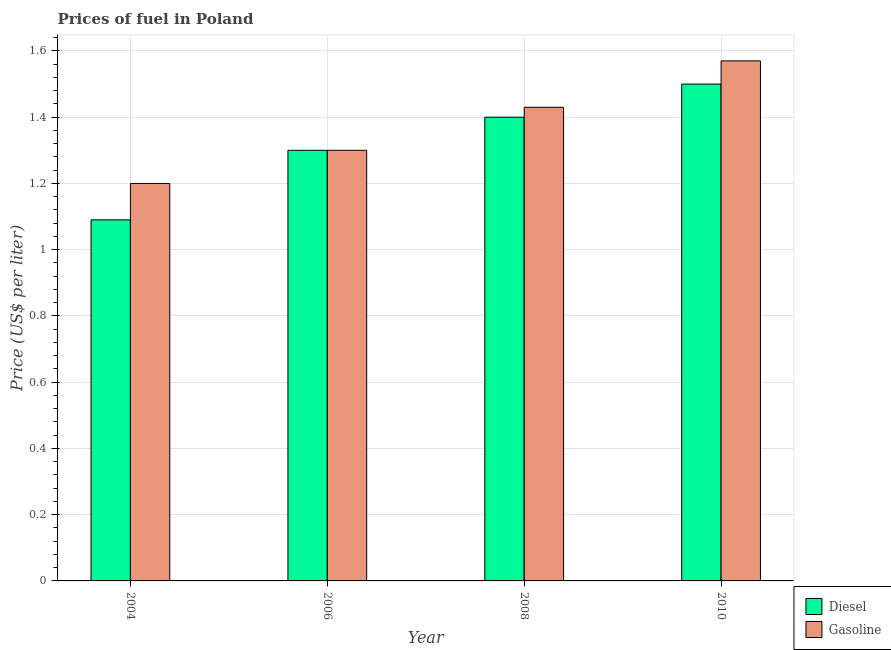How many groups of bars are there?
Offer a very short reply. 4. Are the number of bars on each tick of the X-axis equal?
Give a very brief answer. Yes. How many bars are there on the 1st tick from the right?
Offer a terse response. 2. What is the label of the 4th group of bars from the left?
Your answer should be very brief. 2010. What is the gasoline price in 2010?
Keep it short and to the point. 1.57. Across all years, what is the maximum gasoline price?
Ensure brevity in your answer.  1.57. Across all years, what is the minimum diesel price?
Offer a terse response. 1.09. In which year was the gasoline price maximum?
Your answer should be very brief. 2010. In which year was the diesel price minimum?
Your response must be concise. 2004. What is the total diesel price in the graph?
Offer a very short reply. 5.29. What is the difference between the diesel price in 2008 and that in 2010?
Make the answer very short. -0.1. What is the difference between the diesel price in 2008 and the gasoline price in 2004?
Ensure brevity in your answer.  0.31. What is the average gasoline price per year?
Ensure brevity in your answer.  1.38. In the year 2006, what is the difference between the gasoline price and diesel price?
Give a very brief answer. 0. In how many years, is the diesel price greater than 1.08 US$ per litre?
Your answer should be compact. 4. What is the ratio of the diesel price in 2004 to that in 2006?
Offer a terse response. 0.84. Is the diesel price in 2004 less than that in 2008?
Make the answer very short. Yes. Is the difference between the gasoline price in 2004 and 2008 greater than the difference between the diesel price in 2004 and 2008?
Give a very brief answer. No. What is the difference between the highest and the second highest gasoline price?
Keep it short and to the point. 0.14. What is the difference between the highest and the lowest diesel price?
Your answer should be very brief. 0.41. In how many years, is the diesel price greater than the average diesel price taken over all years?
Provide a short and direct response. 2. Is the sum of the diesel price in 2004 and 2008 greater than the maximum gasoline price across all years?
Offer a very short reply. Yes. What does the 1st bar from the left in 2006 represents?
Give a very brief answer. Diesel. What does the 1st bar from the right in 2010 represents?
Offer a very short reply. Gasoline. How many bars are there?
Your response must be concise. 8. Are all the bars in the graph horizontal?
Ensure brevity in your answer.  No. What is the title of the graph?
Provide a short and direct response. Prices of fuel in Poland. What is the label or title of the X-axis?
Your response must be concise. Year. What is the label or title of the Y-axis?
Your response must be concise. Price (US$ per liter). What is the Price (US$ per liter) in Diesel in 2004?
Your answer should be very brief. 1.09. What is the Price (US$ per liter) of Diesel in 2006?
Ensure brevity in your answer.  1.3. What is the Price (US$ per liter) of Gasoline in 2006?
Offer a very short reply. 1.3. What is the Price (US$ per liter) of Gasoline in 2008?
Your response must be concise. 1.43. What is the Price (US$ per liter) of Diesel in 2010?
Make the answer very short. 1.5. What is the Price (US$ per liter) in Gasoline in 2010?
Offer a terse response. 1.57. Across all years, what is the maximum Price (US$ per liter) in Gasoline?
Your answer should be very brief. 1.57. Across all years, what is the minimum Price (US$ per liter) of Diesel?
Offer a terse response. 1.09. Across all years, what is the minimum Price (US$ per liter) of Gasoline?
Offer a terse response. 1.2. What is the total Price (US$ per liter) of Diesel in the graph?
Offer a very short reply. 5.29. What is the difference between the Price (US$ per liter) in Diesel in 2004 and that in 2006?
Provide a succinct answer. -0.21. What is the difference between the Price (US$ per liter) in Gasoline in 2004 and that in 2006?
Make the answer very short. -0.1. What is the difference between the Price (US$ per liter) in Diesel in 2004 and that in 2008?
Offer a very short reply. -0.31. What is the difference between the Price (US$ per liter) of Gasoline in 2004 and that in 2008?
Offer a very short reply. -0.23. What is the difference between the Price (US$ per liter) of Diesel in 2004 and that in 2010?
Provide a short and direct response. -0.41. What is the difference between the Price (US$ per liter) in Gasoline in 2004 and that in 2010?
Make the answer very short. -0.37. What is the difference between the Price (US$ per liter) in Gasoline in 2006 and that in 2008?
Keep it short and to the point. -0.13. What is the difference between the Price (US$ per liter) of Diesel in 2006 and that in 2010?
Your response must be concise. -0.2. What is the difference between the Price (US$ per liter) in Gasoline in 2006 and that in 2010?
Provide a short and direct response. -0.27. What is the difference between the Price (US$ per liter) of Gasoline in 2008 and that in 2010?
Make the answer very short. -0.14. What is the difference between the Price (US$ per liter) of Diesel in 2004 and the Price (US$ per liter) of Gasoline in 2006?
Ensure brevity in your answer.  -0.21. What is the difference between the Price (US$ per liter) of Diesel in 2004 and the Price (US$ per liter) of Gasoline in 2008?
Provide a short and direct response. -0.34. What is the difference between the Price (US$ per liter) of Diesel in 2004 and the Price (US$ per liter) of Gasoline in 2010?
Provide a succinct answer. -0.48. What is the difference between the Price (US$ per liter) of Diesel in 2006 and the Price (US$ per liter) of Gasoline in 2008?
Make the answer very short. -0.13. What is the difference between the Price (US$ per liter) of Diesel in 2006 and the Price (US$ per liter) of Gasoline in 2010?
Your response must be concise. -0.27. What is the difference between the Price (US$ per liter) in Diesel in 2008 and the Price (US$ per liter) in Gasoline in 2010?
Make the answer very short. -0.17. What is the average Price (US$ per liter) of Diesel per year?
Keep it short and to the point. 1.32. What is the average Price (US$ per liter) in Gasoline per year?
Offer a very short reply. 1.38. In the year 2004, what is the difference between the Price (US$ per liter) of Diesel and Price (US$ per liter) of Gasoline?
Offer a very short reply. -0.11. In the year 2008, what is the difference between the Price (US$ per liter) in Diesel and Price (US$ per liter) in Gasoline?
Make the answer very short. -0.03. In the year 2010, what is the difference between the Price (US$ per liter) of Diesel and Price (US$ per liter) of Gasoline?
Provide a succinct answer. -0.07. What is the ratio of the Price (US$ per liter) in Diesel in 2004 to that in 2006?
Your answer should be compact. 0.84. What is the ratio of the Price (US$ per liter) in Diesel in 2004 to that in 2008?
Your response must be concise. 0.78. What is the ratio of the Price (US$ per liter) in Gasoline in 2004 to that in 2008?
Offer a terse response. 0.84. What is the ratio of the Price (US$ per liter) in Diesel in 2004 to that in 2010?
Keep it short and to the point. 0.73. What is the ratio of the Price (US$ per liter) in Gasoline in 2004 to that in 2010?
Your answer should be compact. 0.76. What is the ratio of the Price (US$ per liter) of Gasoline in 2006 to that in 2008?
Give a very brief answer. 0.91. What is the ratio of the Price (US$ per liter) of Diesel in 2006 to that in 2010?
Ensure brevity in your answer.  0.87. What is the ratio of the Price (US$ per liter) in Gasoline in 2006 to that in 2010?
Give a very brief answer. 0.83. What is the ratio of the Price (US$ per liter) in Diesel in 2008 to that in 2010?
Offer a very short reply. 0.93. What is the ratio of the Price (US$ per liter) of Gasoline in 2008 to that in 2010?
Your response must be concise. 0.91. What is the difference between the highest and the second highest Price (US$ per liter) in Gasoline?
Offer a very short reply. 0.14. What is the difference between the highest and the lowest Price (US$ per liter) in Diesel?
Your response must be concise. 0.41. What is the difference between the highest and the lowest Price (US$ per liter) in Gasoline?
Give a very brief answer. 0.37. 